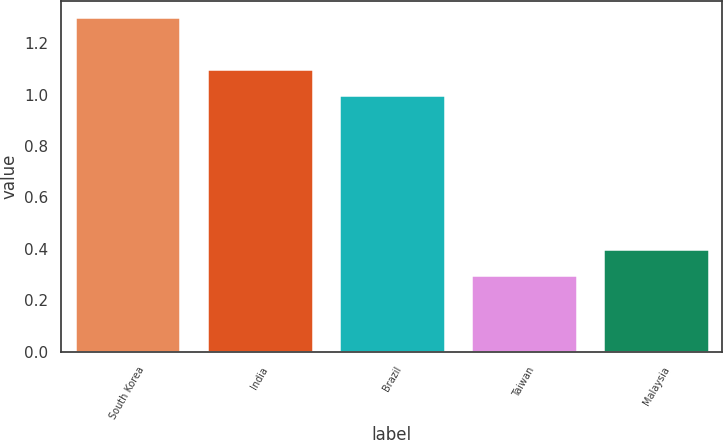<chart> <loc_0><loc_0><loc_500><loc_500><bar_chart><fcel>South Korea<fcel>India<fcel>Brazil<fcel>Taiwan<fcel>Malaysia<nl><fcel>1.3<fcel>1.1<fcel>1<fcel>0.3<fcel>0.4<nl></chart> 